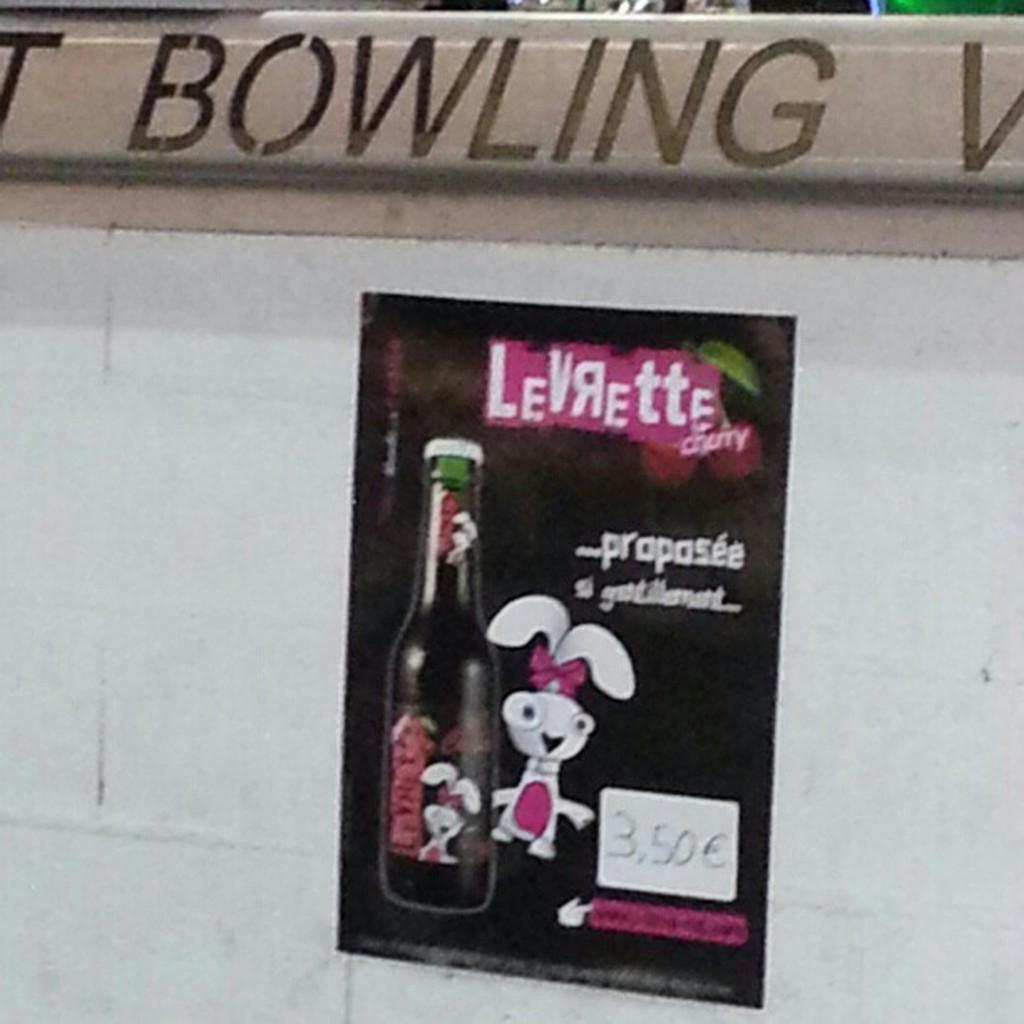What sport do they offer ?
Offer a very short reply. Bowling. What flavor is the drink?
Offer a terse response. Cherry. 